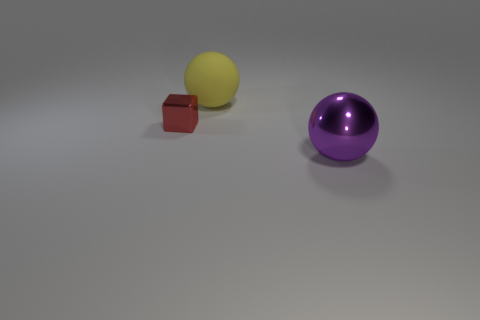Are there the same number of small objects that are right of the tiny red shiny object and big yellow things that are behind the yellow ball?
Ensure brevity in your answer.  Yes. What is the material of the thing that is both on the right side of the tiny red metallic block and in front of the large yellow matte thing?
Your answer should be very brief. Metal. There is a red object; is its size the same as the ball in front of the yellow matte thing?
Make the answer very short. No. How many other things are there of the same color as the cube?
Offer a terse response. 0. Is the number of shiny spheres that are behind the big yellow matte thing greater than the number of purple objects?
Give a very brief answer. No. There is a large thing that is behind the big sphere that is to the right of the big ball that is behind the large purple metallic thing; what color is it?
Offer a terse response. Yellow. Do the purple thing and the red cube have the same material?
Your answer should be compact. Yes. Are there any things of the same size as the purple metallic ball?
Your response must be concise. Yes. There is a yellow sphere that is the same size as the purple ball; what is its material?
Your answer should be compact. Rubber. Are there any other purple shiny objects that have the same shape as the purple object?
Make the answer very short. No. 